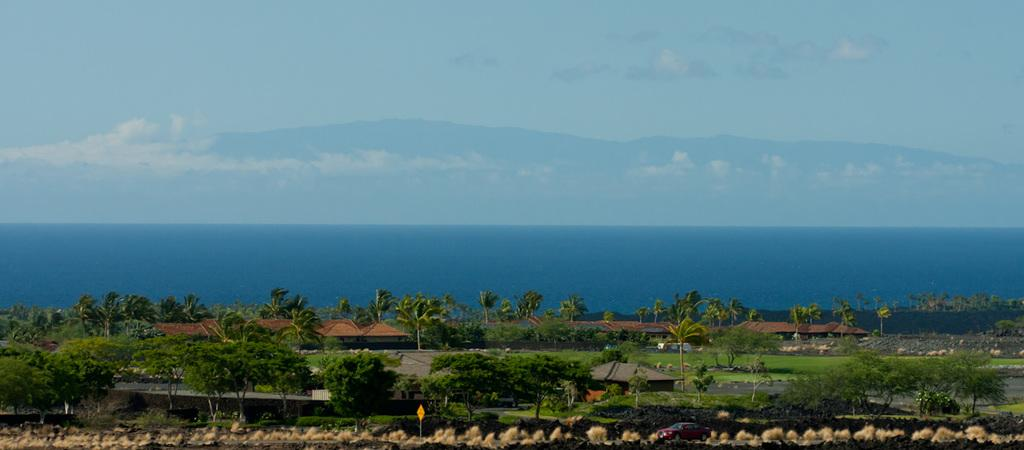What type of natural elements can be seen in the image? There are trees and an ocean visible in the image. What type of man-made structures are present in the image? There are houses in the image. What is visible in the background of the image? There are hills and the sky visible in the background of the image. What is the condition of the sky in the image? The sky has clouds in it. What type of marble is being used to decorate the event in the image? There is no event or marble present in the image. What type of feast is being prepared in the image? There is no feast or preparation visible in the image. 